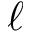Convert formula to latex. <formula><loc_0><loc_0><loc_500><loc_500>\ell</formula> 